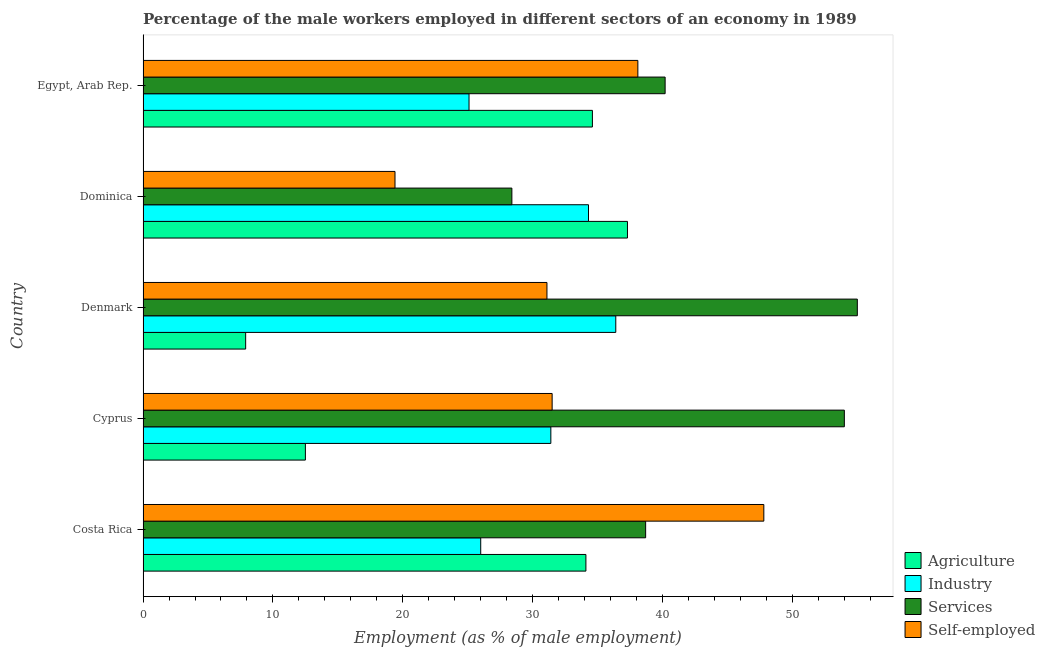Are the number of bars per tick equal to the number of legend labels?
Provide a succinct answer. Yes. Are the number of bars on each tick of the Y-axis equal?
Give a very brief answer. Yes. What is the label of the 1st group of bars from the top?
Offer a very short reply. Egypt, Arab Rep. In how many cases, is the number of bars for a given country not equal to the number of legend labels?
Your response must be concise. 0. What is the percentage of male workers in industry in Cyprus?
Offer a terse response. 31.4. Across all countries, what is the maximum percentage of male workers in industry?
Provide a short and direct response. 36.4. Across all countries, what is the minimum percentage of male workers in services?
Your response must be concise. 28.4. In which country was the percentage of male workers in services minimum?
Make the answer very short. Dominica. What is the total percentage of male workers in agriculture in the graph?
Make the answer very short. 126.4. What is the difference between the percentage of male workers in agriculture in Egypt, Arab Rep. and the percentage of male workers in services in Dominica?
Offer a very short reply. 6.2. What is the average percentage of self employed male workers per country?
Provide a short and direct response. 33.58. What is the difference between the percentage of self employed male workers and percentage of male workers in industry in Dominica?
Provide a succinct answer. -14.9. Is the difference between the percentage of male workers in agriculture in Costa Rica and Egypt, Arab Rep. greater than the difference between the percentage of self employed male workers in Costa Rica and Egypt, Arab Rep.?
Your response must be concise. No. What is the difference between the highest and the lowest percentage of male workers in services?
Provide a short and direct response. 26.6. What does the 4th bar from the top in Denmark represents?
Provide a succinct answer. Agriculture. What does the 1st bar from the bottom in Costa Rica represents?
Your answer should be compact. Agriculture. Are all the bars in the graph horizontal?
Ensure brevity in your answer.  Yes. How many countries are there in the graph?
Give a very brief answer. 5. Are the values on the major ticks of X-axis written in scientific E-notation?
Give a very brief answer. No. Does the graph contain any zero values?
Make the answer very short. No. How many legend labels are there?
Provide a short and direct response. 4. What is the title of the graph?
Your answer should be compact. Percentage of the male workers employed in different sectors of an economy in 1989. Does "First 20% of population" appear as one of the legend labels in the graph?
Keep it short and to the point. No. What is the label or title of the X-axis?
Ensure brevity in your answer.  Employment (as % of male employment). What is the label or title of the Y-axis?
Offer a terse response. Country. What is the Employment (as % of male employment) in Agriculture in Costa Rica?
Your response must be concise. 34.1. What is the Employment (as % of male employment) of Industry in Costa Rica?
Keep it short and to the point. 26. What is the Employment (as % of male employment) in Services in Costa Rica?
Your answer should be compact. 38.7. What is the Employment (as % of male employment) of Self-employed in Costa Rica?
Ensure brevity in your answer.  47.8. What is the Employment (as % of male employment) of Industry in Cyprus?
Give a very brief answer. 31.4. What is the Employment (as % of male employment) of Self-employed in Cyprus?
Your answer should be compact. 31.5. What is the Employment (as % of male employment) in Agriculture in Denmark?
Your answer should be very brief. 7.9. What is the Employment (as % of male employment) in Industry in Denmark?
Ensure brevity in your answer.  36.4. What is the Employment (as % of male employment) in Services in Denmark?
Your answer should be compact. 55. What is the Employment (as % of male employment) in Self-employed in Denmark?
Your response must be concise. 31.1. What is the Employment (as % of male employment) of Agriculture in Dominica?
Ensure brevity in your answer.  37.3. What is the Employment (as % of male employment) of Industry in Dominica?
Provide a short and direct response. 34.3. What is the Employment (as % of male employment) in Services in Dominica?
Provide a succinct answer. 28.4. What is the Employment (as % of male employment) of Self-employed in Dominica?
Offer a very short reply. 19.4. What is the Employment (as % of male employment) of Agriculture in Egypt, Arab Rep.?
Give a very brief answer. 34.6. What is the Employment (as % of male employment) in Industry in Egypt, Arab Rep.?
Give a very brief answer. 25.1. What is the Employment (as % of male employment) of Services in Egypt, Arab Rep.?
Your answer should be very brief. 40.2. What is the Employment (as % of male employment) of Self-employed in Egypt, Arab Rep.?
Your answer should be very brief. 38.1. Across all countries, what is the maximum Employment (as % of male employment) in Agriculture?
Your response must be concise. 37.3. Across all countries, what is the maximum Employment (as % of male employment) in Industry?
Make the answer very short. 36.4. Across all countries, what is the maximum Employment (as % of male employment) in Self-employed?
Your answer should be very brief. 47.8. Across all countries, what is the minimum Employment (as % of male employment) of Agriculture?
Make the answer very short. 7.9. Across all countries, what is the minimum Employment (as % of male employment) in Industry?
Make the answer very short. 25.1. Across all countries, what is the minimum Employment (as % of male employment) of Services?
Offer a very short reply. 28.4. Across all countries, what is the minimum Employment (as % of male employment) in Self-employed?
Provide a short and direct response. 19.4. What is the total Employment (as % of male employment) of Agriculture in the graph?
Your answer should be compact. 126.4. What is the total Employment (as % of male employment) in Industry in the graph?
Keep it short and to the point. 153.2. What is the total Employment (as % of male employment) of Services in the graph?
Your answer should be compact. 216.3. What is the total Employment (as % of male employment) in Self-employed in the graph?
Keep it short and to the point. 167.9. What is the difference between the Employment (as % of male employment) of Agriculture in Costa Rica and that in Cyprus?
Your answer should be compact. 21.6. What is the difference between the Employment (as % of male employment) in Industry in Costa Rica and that in Cyprus?
Your answer should be compact. -5.4. What is the difference between the Employment (as % of male employment) of Services in Costa Rica and that in Cyprus?
Ensure brevity in your answer.  -15.3. What is the difference between the Employment (as % of male employment) in Agriculture in Costa Rica and that in Denmark?
Your answer should be compact. 26.2. What is the difference between the Employment (as % of male employment) in Services in Costa Rica and that in Denmark?
Offer a very short reply. -16.3. What is the difference between the Employment (as % of male employment) of Agriculture in Costa Rica and that in Dominica?
Make the answer very short. -3.2. What is the difference between the Employment (as % of male employment) in Industry in Costa Rica and that in Dominica?
Give a very brief answer. -8.3. What is the difference between the Employment (as % of male employment) of Services in Costa Rica and that in Dominica?
Ensure brevity in your answer.  10.3. What is the difference between the Employment (as % of male employment) of Self-employed in Costa Rica and that in Dominica?
Ensure brevity in your answer.  28.4. What is the difference between the Employment (as % of male employment) in Agriculture in Costa Rica and that in Egypt, Arab Rep.?
Offer a terse response. -0.5. What is the difference between the Employment (as % of male employment) in Industry in Costa Rica and that in Egypt, Arab Rep.?
Provide a short and direct response. 0.9. What is the difference between the Employment (as % of male employment) of Services in Costa Rica and that in Egypt, Arab Rep.?
Keep it short and to the point. -1.5. What is the difference between the Employment (as % of male employment) in Self-employed in Costa Rica and that in Egypt, Arab Rep.?
Give a very brief answer. 9.7. What is the difference between the Employment (as % of male employment) in Agriculture in Cyprus and that in Denmark?
Your answer should be very brief. 4.6. What is the difference between the Employment (as % of male employment) in Industry in Cyprus and that in Denmark?
Your answer should be very brief. -5. What is the difference between the Employment (as % of male employment) in Services in Cyprus and that in Denmark?
Offer a terse response. -1. What is the difference between the Employment (as % of male employment) in Agriculture in Cyprus and that in Dominica?
Offer a very short reply. -24.8. What is the difference between the Employment (as % of male employment) in Industry in Cyprus and that in Dominica?
Keep it short and to the point. -2.9. What is the difference between the Employment (as % of male employment) of Services in Cyprus and that in Dominica?
Offer a very short reply. 25.6. What is the difference between the Employment (as % of male employment) of Self-employed in Cyprus and that in Dominica?
Ensure brevity in your answer.  12.1. What is the difference between the Employment (as % of male employment) in Agriculture in Cyprus and that in Egypt, Arab Rep.?
Your response must be concise. -22.1. What is the difference between the Employment (as % of male employment) of Industry in Cyprus and that in Egypt, Arab Rep.?
Make the answer very short. 6.3. What is the difference between the Employment (as % of male employment) in Services in Cyprus and that in Egypt, Arab Rep.?
Offer a terse response. 13.8. What is the difference between the Employment (as % of male employment) of Self-employed in Cyprus and that in Egypt, Arab Rep.?
Provide a succinct answer. -6.6. What is the difference between the Employment (as % of male employment) in Agriculture in Denmark and that in Dominica?
Your response must be concise. -29.4. What is the difference between the Employment (as % of male employment) of Industry in Denmark and that in Dominica?
Your response must be concise. 2.1. What is the difference between the Employment (as % of male employment) of Services in Denmark and that in Dominica?
Make the answer very short. 26.6. What is the difference between the Employment (as % of male employment) of Agriculture in Denmark and that in Egypt, Arab Rep.?
Keep it short and to the point. -26.7. What is the difference between the Employment (as % of male employment) in Industry in Denmark and that in Egypt, Arab Rep.?
Your answer should be compact. 11.3. What is the difference between the Employment (as % of male employment) in Services in Denmark and that in Egypt, Arab Rep.?
Provide a succinct answer. 14.8. What is the difference between the Employment (as % of male employment) of Industry in Dominica and that in Egypt, Arab Rep.?
Give a very brief answer. 9.2. What is the difference between the Employment (as % of male employment) of Services in Dominica and that in Egypt, Arab Rep.?
Your answer should be very brief. -11.8. What is the difference between the Employment (as % of male employment) of Self-employed in Dominica and that in Egypt, Arab Rep.?
Your answer should be compact. -18.7. What is the difference between the Employment (as % of male employment) in Agriculture in Costa Rica and the Employment (as % of male employment) in Industry in Cyprus?
Provide a succinct answer. 2.7. What is the difference between the Employment (as % of male employment) of Agriculture in Costa Rica and the Employment (as % of male employment) of Services in Cyprus?
Give a very brief answer. -19.9. What is the difference between the Employment (as % of male employment) of Industry in Costa Rica and the Employment (as % of male employment) of Services in Cyprus?
Give a very brief answer. -28. What is the difference between the Employment (as % of male employment) of Services in Costa Rica and the Employment (as % of male employment) of Self-employed in Cyprus?
Give a very brief answer. 7.2. What is the difference between the Employment (as % of male employment) in Agriculture in Costa Rica and the Employment (as % of male employment) in Services in Denmark?
Your answer should be compact. -20.9. What is the difference between the Employment (as % of male employment) in Industry in Costa Rica and the Employment (as % of male employment) in Services in Denmark?
Your answer should be compact. -29. What is the difference between the Employment (as % of male employment) of Services in Costa Rica and the Employment (as % of male employment) of Self-employed in Denmark?
Your answer should be very brief. 7.6. What is the difference between the Employment (as % of male employment) of Agriculture in Costa Rica and the Employment (as % of male employment) of Industry in Dominica?
Your answer should be compact. -0.2. What is the difference between the Employment (as % of male employment) in Agriculture in Costa Rica and the Employment (as % of male employment) in Services in Dominica?
Offer a very short reply. 5.7. What is the difference between the Employment (as % of male employment) of Agriculture in Costa Rica and the Employment (as % of male employment) of Self-employed in Dominica?
Keep it short and to the point. 14.7. What is the difference between the Employment (as % of male employment) of Industry in Costa Rica and the Employment (as % of male employment) of Services in Dominica?
Provide a short and direct response. -2.4. What is the difference between the Employment (as % of male employment) in Services in Costa Rica and the Employment (as % of male employment) in Self-employed in Dominica?
Offer a terse response. 19.3. What is the difference between the Employment (as % of male employment) of Agriculture in Costa Rica and the Employment (as % of male employment) of Services in Egypt, Arab Rep.?
Provide a short and direct response. -6.1. What is the difference between the Employment (as % of male employment) in Agriculture in Costa Rica and the Employment (as % of male employment) in Self-employed in Egypt, Arab Rep.?
Offer a terse response. -4. What is the difference between the Employment (as % of male employment) in Industry in Costa Rica and the Employment (as % of male employment) in Self-employed in Egypt, Arab Rep.?
Provide a short and direct response. -12.1. What is the difference between the Employment (as % of male employment) of Agriculture in Cyprus and the Employment (as % of male employment) of Industry in Denmark?
Give a very brief answer. -23.9. What is the difference between the Employment (as % of male employment) of Agriculture in Cyprus and the Employment (as % of male employment) of Services in Denmark?
Provide a short and direct response. -42.5. What is the difference between the Employment (as % of male employment) in Agriculture in Cyprus and the Employment (as % of male employment) in Self-employed in Denmark?
Make the answer very short. -18.6. What is the difference between the Employment (as % of male employment) of Industry in Cyprus and the Employment (as % of male employment) of Services in Denmark?
Make the answer very short. -23.6. What is the difference between the Employment (as % of male employment) in Industry in Cyprus and the Employment (as % of male employment) in Self-employed in Denmark?
Your answer should be very brief. 0.3. What is the difference between the Employment (as % of male employment) in Services in Cyprus and the Employment (as % of male employment) in Self-employed in Denmark?
Offer a very short reply. 22.9. What is the difference between the Employment (as % of male employment) of Agriculture in Cyprus and the Employment (as % of male employment) of Industry in Dominica?
Your answer should be very brief. -21.8. What is the difference between the Employment (as % of male employment) of Agriculture in Cyprus and the Employment (as % of male employment) of Services in Dominica?
Your response must be concise. -15.9. What is the difference between the Employment (as % of male employment) in Industry in Cyprus and the Employment (as % of male employment) in Self-employed in Dominica?
Keep it short and to the point. 12. What is the difference between the Employment (as % of male employment) in Services in Cyprus and the Employment (as % of male employment) in Self-employed in Dominica?
Provide a short and direct response. 34.6. What is the difference between the Employment (as % of male employment) of Agriculture in Cyprus and the Employment (as % of male employment) of Industry in Egypt, Arab Rep.?
Keep it short and to the point. -12.6. What is the difference between the Employment (as % of male employment) of Agriculture in Cyprus and the Employment (as % of male employment) of Services in Egypt, Arab Rep.?
Your answer should be very brief. -27.7. What is the difference between the Employment (as % of male employment) in Agriculture in Cyprus and the Employment (as % of male employment) in Self-employed in Egypt, Arab Rep.?
Make the answer very short. -25.6. What is the difference between the Employment (as % of male employment) of Industry in Cyprus and the Employment (as % of male employment) of Self-employed in Egypt, Arab Rep.?
Provide a short and direct response. -6.7. What is the difference between the Employment (as % of male employment) of Services in Cyprus and the Employment (as % of male employment) of Self-employed in Egypt, Arab Rep.?
Keep it short and to the point. 15.9. What is the difference between the Employment (as % of male employment) in Agriculture in Denmark and the Employment (as % of male employment) in Industry in Dominica?
Provide a short and direct response. -26.4. What is the difference between the Employment (as % of male employment) of Agriculture in Denmark and the Employment (as % of male employment) of Services in Dominica?
Ensure brevity in your answer.  -20.5. What is the difference between the Employment (as % of male employment) in Industry in Denmark and the Employment (as % of male employment) in Self-employed in Dominica?
Make the answer very short. 17. What is the difference between the Employment (as % of male employment) of Services in Denmark and the Employment (as % of male employment) of Self-employed in Dominica?
Provide a succinct answer. 35.6. What is the difference between the Employment (as % of male employment) in Agriculture in Denmark and the Employment (as % of male employment) in Industry in Egypt, Arab Rep.?
Your answer should be very brief. -17.2. What is the difference between the Employment (as % of male employment) in Agriculture in Denmark and the Employment (as % of male employment) in Services in Egypt, Arab Rep.?
Ensure brevity in your answer.  -32.3. What is the difference between the Employment (as % of male employment) of Agriculture in Denmark and the Employment (as % of male employment) of Self-employed in Egypt, Arab Rep.?
Provide a succinct answer. -30.2. What is the difference between the Employment (as % of male employment) in Services in Denmark and the Employment (as % of male employment) in Self-employed in Egypt, Arab Rep.?
Give a very brief answer. 16.9. What is the difference between the Employment (as % of male employment) of Agriculture in Dominica and the Employment (as % of male employment) of Industry in Egypt, Arab Rep.?
Your response must be concise. 12.2. What is the difference between the Employment (as % of male employment) of Services in Dominica and the Employment (as % of male employment) of Self-employed in Egypt, Arab Rep.?
Your answer should be compact. -9.7. What is the average Employment (as % of male employment) in Agriculture per country?
Offer a very short reply. 25.28. What is the average Employment (as % of male employment) in Industry per country?
Make the answer very short. 30.64. What is the average Employment (as % of male employment) in Services per country?
Provide a short and direct response. 43.26. What is the average Employment (as % of male employment) of Self-employed per country?
Your answer should be compact. 33.58. What is the difference between the Employment (as % of male employment) in Agriculture and Employment (as % of male employment) in Services in Costa Rica?
Provide a succinct answer. -4.6. What is the difference between the Employment (as % of male employment) in Agriculture and Employment (as % of male employment) in Self-employed in Costa Rica?
Give a very brief answer. -13.7. What is the difference between the Employment (as % of male employment) of Industry and Employment (as % of male employment) of Self-employed in Costa Rica?
Offer a terse response. -21.8. What is the difference between the Employment (as % of male employment) of Services and Employment (as % of male employment) of Self-employed in Costa Rica?
Offer a very short reply. -9.1. What is the difference between the Employment (as % of male employment) of Agriculture and Employment (as % of male employment) of Industry in Cyprus?
Your response must be concise. -18.9. What is the difference between the Employment (as % of male employment) in Agriculture and Employment (as % of male employment) in Services in Cyprus?
Keep it short and to the point. -41.5. What is the difference between the Employment (as % of male employment) of Agriculture and Employment (as % of male employment) of Self-employed in Cyprus?
Your answer should be very brief. -19. What is the difference between the Employment (as % of male employment) of Industry and Employment (as % of male employment) of Services in Cyprus?
Your response must be concise. -22.6. What is the difference between the Employment (as % of male employment) of Industry and Employment (as % of male employment) of Self-employed in Cyprus?
Provide a succinct answer. -0.1. What is the difference between the Employment (as % of male employment) of Services and Employment (as % of male employment) of Self-employed in Cyprus?
Your response must be concise. 22.5. What is the difference between the Employment (as % of male employment) of Agriculture and Employment (as % of male employment) of Industry in Denmark?
Make the answer very short. -28.5. What is the difference between the Employment (as % of male employment) in Agriculture and Employment (as % of male employment) in Services in Denmark?
Your response must be concise. -47.1. What is the difference between the Employment (as % of male employment) in Agriculture and Employment (as % of male employment) in Self-employed in Denmark?
Give a very brief answer. -23.2. What is the difference between the Employment (as % of male employment) of Industry and Employment (as % of male employment) of Services in Denmark?
Give a very brief answer. -18.6. What is the difference between the Employment (as % of male employment) of Industry and Employment (as % of male employment) of Self-employed in Denmark?
Give a very brief answer. 5.3. What is the difference between the Employment (as % of male employment) of Services and Employment (as % of male employment) of Self-employed in Denmark?
Make the answer very short. 23.9. What is the difference between the Employment (as % of male employment) of Agriculture and Employment (as % of male employment) of Industry in Dominica?
Offer a very short reply. 3. What is the difference between the Employment (as % of male employment) in Agriculture and Employment (as % of male employment) in Services in Dominica?
Make the answer very short. 8.9. What is the difference between the Employment (as % of male employment) in Industry and Employment (as % of male employment) in Self-employed in Dominica?
Offer a terse response. 14.9. What is the difference between the Employment (as % of male employment) in Services and Employment (as % of male employment) in Self-employed in Dominica?
Give a very brief answer. 9. What is the difference between the Employment (as % of male employment) in Industry and Employment (as % of male employment) in Services in Egypt, Arab Rep.?
Your answer should be compact. -15.1. What is the difference between the Employment (as % of male employment) of Industry and Employment (as % of male employment) of Self-employed in Egypt, Arab Rep.?
Offer a very short reply. -13. What is the ratio of the Employment (as % of male employment) in Agriculture in Costa Rica to that in Cyprus?
Provide a succinct answer. 2.73. What is the ratio of the Employment (as % of male employment) of Industry in Costa Rica to that in Cyprus?
Your answer should be compact. 0.83. What is the ratio of the Employment (as % of male employment) in Services in Costa Rica to that in Cyprus?
Give a very brief answer. 0.72. What is the ratio of the Employment (as % of male employment) in Self-employed in Costa Rica to that in Cyprus?
Keep it short and to the point. 1.52. What is the ratio of the Employment (as % of male employment) in Agriculture in Costa Rica to that in Denmark?
Provide a succinct answer. 4.32. What is the ratio of the Employment (as % of male employment) in Services in Costa Rica to that in Denmark?
Ensure brevity in your answer.  0.7. What is the ratio of the Employment (as % of male employment) in Self-employed in Costa Rica to that in Denmark?
Offer a terse response. 1.54. What is the ratio of the Employment (as % of male employment) in Agriculture in Costa Rica to that in Dominica?
Offer a terse response. 0.91. What is the ratio of the Employment (as % of male employment) of Industry in Costa Rica to that in Dominica?
Ensure brevity in your answer.  0.76. What is the ratio of the Employment (as % of male employment) in Services in Costa Rica to that in Dominica?
Make the answer very short. 1.36. What is the ratio of the Employment (as % of male employment) of Self-employed in Costa Rica to that in Dominica?
Your response must be concise. 2.46. What is the ratio of the Employment (as % of male employment) of Agriculture in Costa Rica to that in Egypt, Arab Rep.?
Your response must be concise. 0.99. What is the ratio of the Employment (as % of male employment) of Industry in Costa Rica to that in Egypt, Arab Rep.?
Your answer should be compact. 1.04. What is the ratio of the Employment (as % of male employment) in Services in Costa Rica to that in Egypt, Arab Rep.?
Keep it short and to the point. 0.96. What is the ratio of the Employment (as % of male employment) of Self-employed in Costa Rica to that in Egypt, Arab Rep.?
Make the answer very short. 1.25. What is the ratio of the Employment (as % of male employment) of Agriculture in Cyprus to that in Denmark?
Provide a short and direct response. 1.58. What is the ratio of the Employment (as % of male employment) of Industry in Cyprus to that in Denmark?
Offer a terse response. 0.86. What is the ratio of the Employment (as % of male employment) of Services in Cyprus to that in Denmark?
Provide a short and direct response. 0.98. What is the ratio of the Employment (as % of male employment) of Self-employed in Cyprus to that in Denmark?
Make the answer very short. 1.01. What is the ratio of the Employment (as % of male employment) in Agriculture in Cyprus to that in Dominica?
Make the answer very short. 0.34. What is the ratio of the Employment (as % of male employment) of Industry in Cyprus to that in Dominica?
Provide a short and direct response. 0.92. What is the ratio of the Employment (as % of male employment) in Services in Cyprus to that in Dominica?
Give a very brief answer. 1.9. What is the ratio of the Employment (as % of male employment) of Self-employed in Cyprus to that in Dominica?
Provide a succinct answer. 1.62. What is the ratio of the Employment (as % of male employment) in Agriculture in Cyprus to that in Egypt, Arab Rep.?
Provide a succinct answer. 0.36. What is the ratio of the Employment (as % of male employment) in Industry in Cyprus to that in Egypt, Arab Rep.?
Provide a succinct answer. 1.25. What is the ratio of the Employment (as % of male employment) of Services in Cyprus to that in Egypt, Arab Rep.?
Give a very brief answer. 1.34. What is the ratio of the Employment (as % of male employment) in Self-employed in Cyprus to that in Egypt, Arab Rep.?
Your answer should be very brief. 0.83. What is the ratio of the Employment (as % of male employment) in Agriculture in Denmark to that in Dominica?
Offer a terse response. 0.21. What is the ratio of the Employment (as % of male employment) in Industry in Denmark to that in Dominica?
Offer a very short reply. 1.06. What is the ratio of the Employment (as % of male employment) of Services in Denmark to that in Dominica?
Make the answer very short. 1.94. What is the ratio of the Employment (as % of male employment) of Self-employed in Denmark to that in Dominica?
Your answer should be compact. 1.6. What is the ratio of the Employment (as % of male employment) of Agriculture in Denmark to that in Egypt, Arab Rep.?
Provide a succinct answer. 0.23. What is the ratio of the Employment (as % of male employment) in Industry in Denmark to that in Egypt, Arab Rep.?
Your answer should be compact. 1.45. What is the ratio of the Employment (as % of male employment) of Services in Denmark to that in Egypt, Arab Rep.?
Offer a very short reply. 1.37. What is the ratio of the Employment (as % of male employment) in Self-employed in Denmark to that in Egypt, Arab Rep.?
Make the answer very short. 0.82. What is the ratio of the Employment (as % of male employment) in Agriculture in Dominica to that in Egypt, Arab Rep.?
Provide a short and direct response. 1.08. What is the ratio of the Employment (as % of male employment) of Industry in Dominica to that in Egypt, Arab Rep.?
Your answer should be compact. 1.37. What is the ratio of the Employment (as % of male employment) of Services in Dominica to that in Egypt, Arab Rep.?
Ensure brevity in your answer.  0.71. What is the ratio of the Employment (as % of male employment) of Self-employed in Dominica to that in Egypt, Arab Rep.?
Provide a succinct answer. 0.51. What is the difference between the highest and the second highest Employment (as % of male employment) of Agriculture?
Offer a terse response. 2.7. What is the difference between the highest and the lowest Employment (as % of male employment) of Agriculture?
Ensure brevity in your answer.  29.4. What is the difference between the highest and the lowest Employment (as % of male employment) in Services?
Offer a terse response. 26.6. What is the difference between the highest and the lowest Employment (as % of male employment) of Self-employed?
Provide a succinct answer. 28.4. 